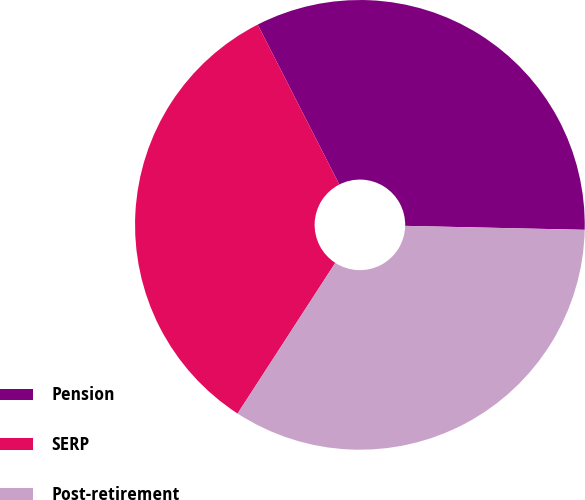Convert chart to OTSL. <chart><loc_0><loc_0><loc_500><loc_500><pie_chart><fcel>Pension<fcel>SERP<fcel>Post-retirement<nl><fcel>32.86%<fcel>33.33%<fcel>33.8%<nl></chart> 